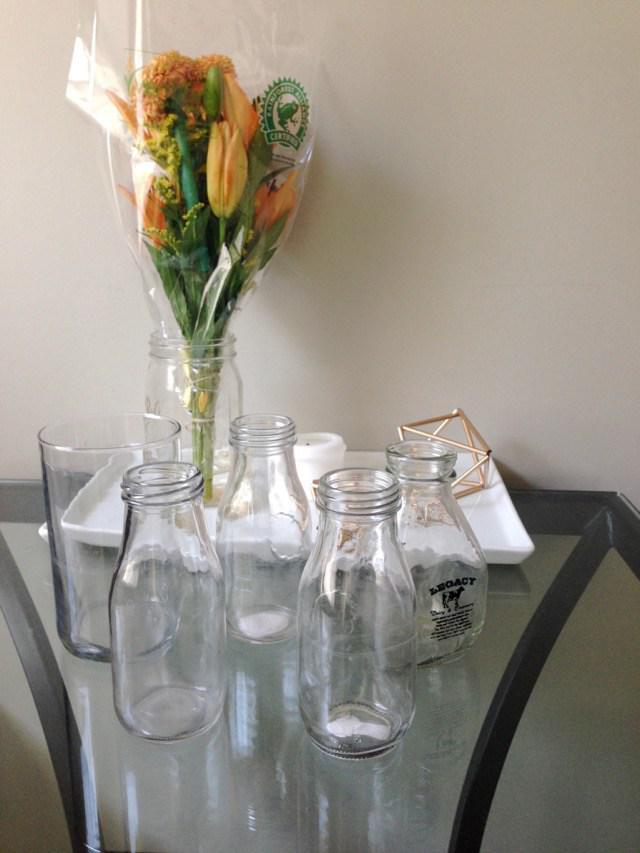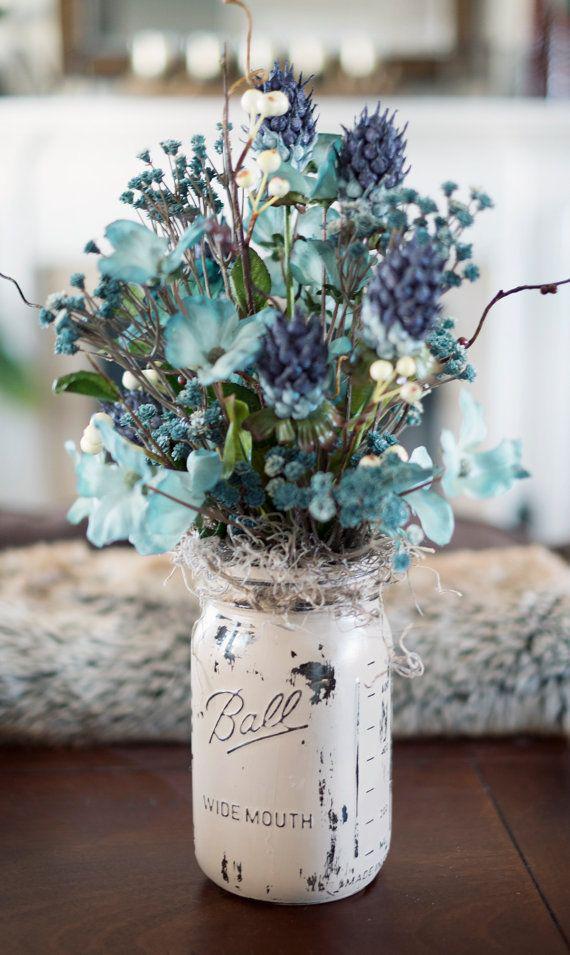The first image is the image on the left, the second image is the image on the right. Assess this claim about the two images: "At least one vase appears bright blue.". Correct or not? Answer yes or no. No. 